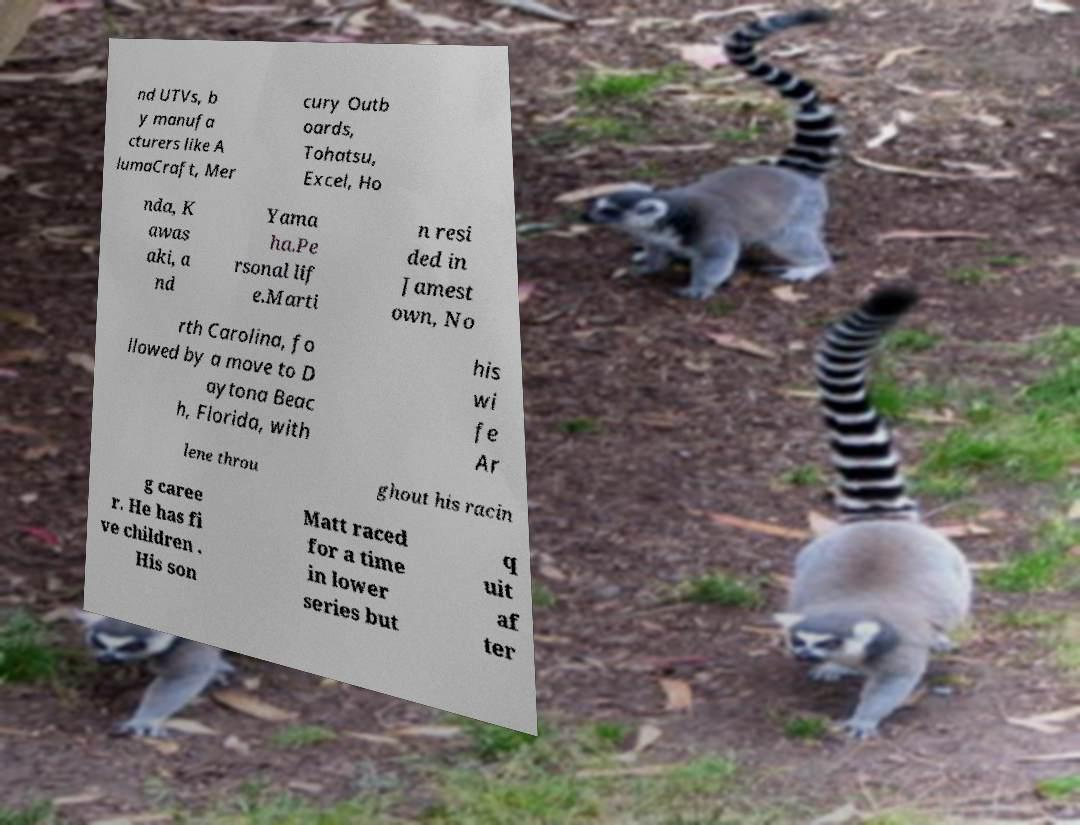What messages or text are displayed in this image? I need them in a readable, typed format. nd UTVs, b y manufa cturers like A lumaCraft, Mer cury Outb oards, Tohatsu, Excel, Ho nda, K awas aki, a nd Yama ha.Pe rsonal lif e.Marti n resi ded in Jamest own, No rth Carolina, fo llowed by a move to D aytona Beac h, Florida, with his wi fe Ar lene throu ghout his racin g caree r. He has fi ve children . His son Matt raced for a time in lower series but q uit af ter 